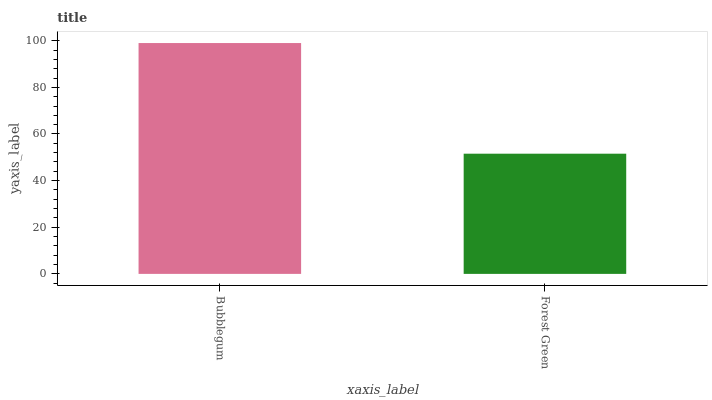Is Forest Green the minimum?
Answer yes or no. Yes. Is Bubblegum the maximum?
Answer yes or no. Yes. Is Forest Green the maximum?
Answer yes or no. No. Is Bubblegum greater than Forest Green?
Answer yes or no. Yes. Is Forest Green less than Bubblegum?
Answer yes or no. Yes. Is Forest Green greater than Bubblegum?
Answer yes or no. No. Is Bubblegum less than Forest Green?
Answer yes or no. No. Is Bubblegum the high median?
Answer yes or no. Yes. Is Forest Green the low median?
Answer yes or no. Yes. Is Forest Green the high median?
Answer yes or no. No. Is Bubblegum the low median?
Answer yes or no. No. 